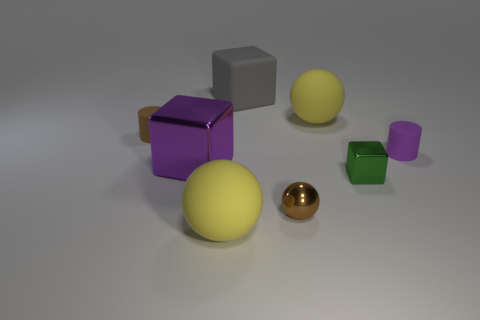What material is the large ball on the right side of the yellow ball in front of the purple rubber thing?
Ensure brevity in your answer.  Rubber. How many other things are the same shape as the large purple metal thing?
Give a very brief answer. 2. There is a tiny metal thing that is behind the tiny metal ball; does it have the same shape as the purple object left of the tiny green block?
Ensure brevity in your answer.  Yes. Are there any other things that are made of the same material as the tiny green block?
Give a very brief answer. Yes. What is the tiny green thing made of?
Keep it short and to the point. Metal. What material is the small purple cylinder in front of the gray rubber thing?
Your response must be concise. Rubber. Is there anything else of the same color as the tiny sphere?
Your answer should be very brief. Yes. What size is the brown thing that is the same material as the purple cylinder?
Keep it short and to the point. Small. What number of small things are red metal blocks or purple metallic objects?
Make the answer very short. 0. There is a yellow matte thing that is to the right of the big rubber sphere in front of the small matte cylinder to the right of the gray rubber object; how big is it?
Offer a terse response. Large. 